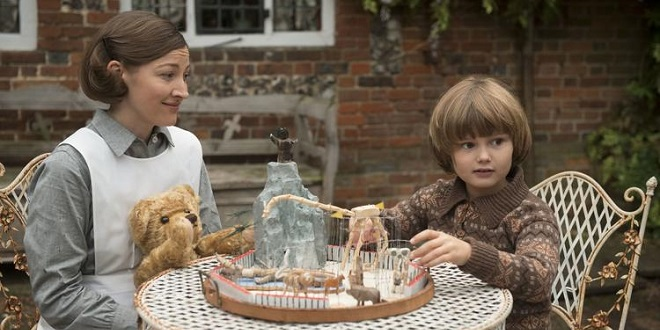What do you think the boy might be thinking about? The boy seems to be deeply fascinated by the toy carousel in front of him. His expression of wonder and curiosity suggests that he might be imagining the toy animals coming to life and going on grand adventures. Perhaps he’s thinking about what it would be like to ride the carousel, or he may be concocting a vivid story involving the animals and their escapades. Can you describe an imaginary adventure the boy might be envisioning? In the boy’s imagination, the carousel transforms into a magical forest where the toy animals come to life. The teddy bear becomes a noble guardian of the forest, while the other animals, like the giraffe and lion, invite the boy to join their journey. Together, they embark on a quest to find a hidden treasure buried deep within the enchanted woods. Along the way, they traverse sparkling rivers, scale mystical mountains, and encounter fantastical creatures like talking birds and kind-hearted dragons. Each step of their adventure brings new excitement and wonder, filling the boy’s heart with joy and astonishment. 